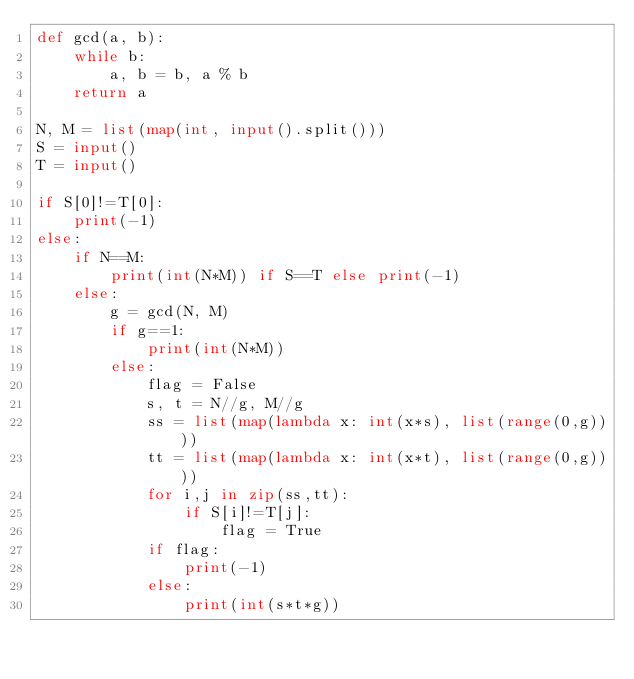Convert code to text. <code><loc_0><loc_0><loc_500><loc_500><_Python_>def gcd(a, b):
    while b:
        a, b = b, a % b
    return a

N, M = list(map(int, input().split()))
S = input()
T = input()

if S[0]!=T[0]:
    print(-1)
else:
    if N==M:
        print(int(N*M)) if S==T else print(-1)
    else:
        g = gcd(N, M)
        if g==1:
            print(int(N*M))
        else:
            flag = False
            s, t = N//g, M//g
            ss = list(map(lambda x: int(x*s), list(range(0,g))))
            tt = list(map(lambda x: int(x*t), list(range(0,g))))
            for i,j in zip(ss,tt):
                if S[i]!=T[j]:
                    flag = True
            if flag:
                print(-1)
            else:
                print(int(s*t*g))</code> 